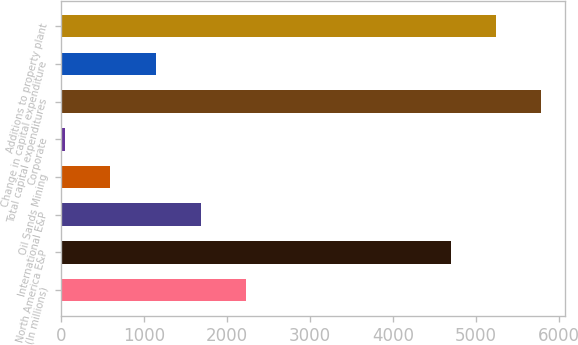Convert chart to OTSL. <chart><loc_0><loc_0><loc_500><loc_500><bar_chart><fcel>(In millions)<fcel>North America E&P<fcel>International E&P<fcel>Oil Sands Mining<fcel>Corporate<fcel>Total capital expenditures<fcel>Change in capital expenditure<fcel>Additions to property plant<nl><fcel>2228.6<fcel>4698<fcel>1684.2<fcel>595.4<fcel>51<fcel>5786.8<fcel>1139.8<fcel>5242.4<nl></chart> 